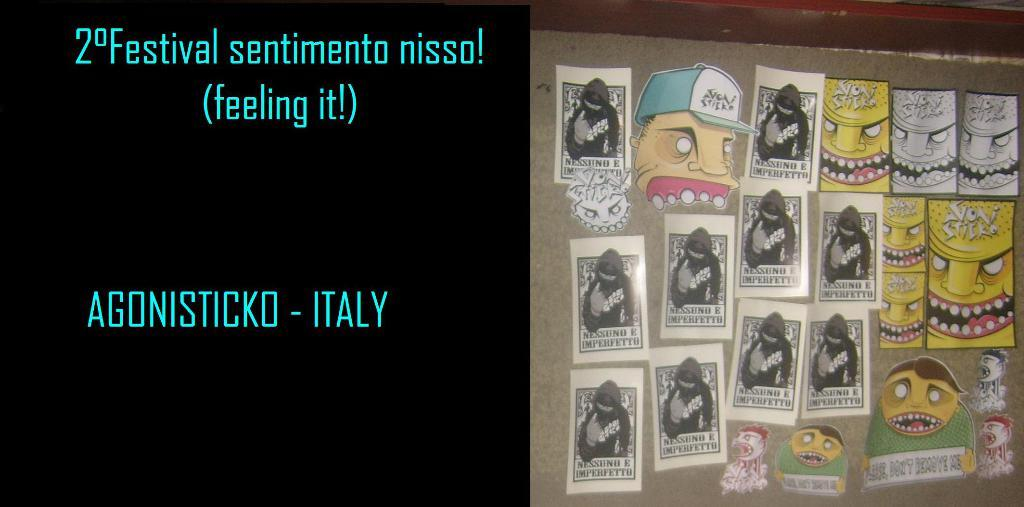<image>
Present a compact description of the photo's key features. A bulletin board with many clippings of cartoons tacked up with a sign that says 2 Festival Sentimento nisso! 